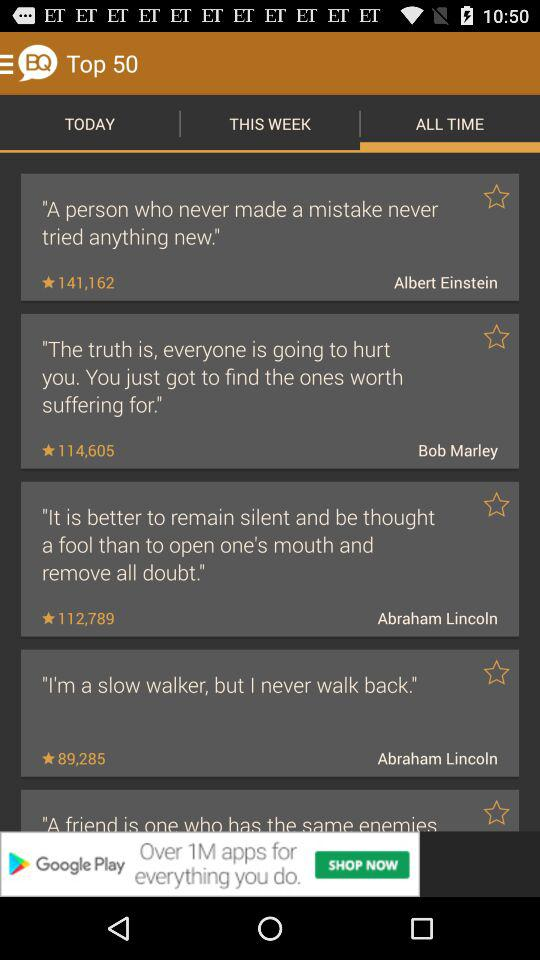What are the ratings of Albert Einstein's statement? The rating is 141,162. 